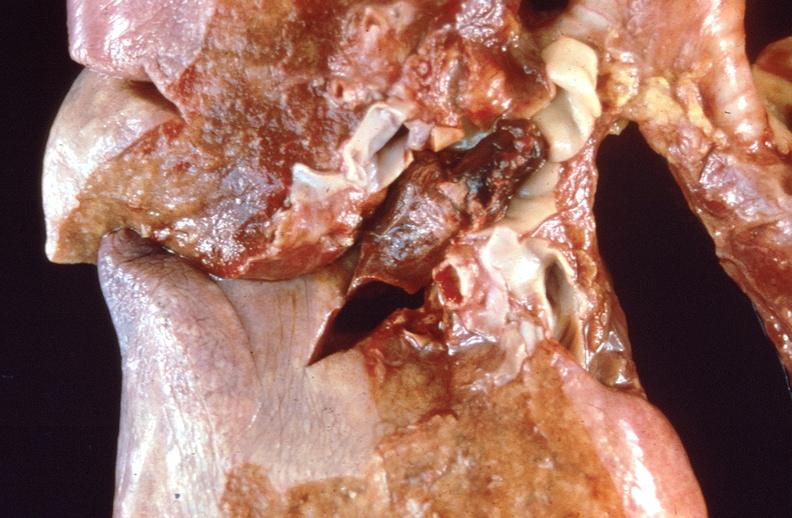where is this?
Answer the question using a single word or phrase. Lung 